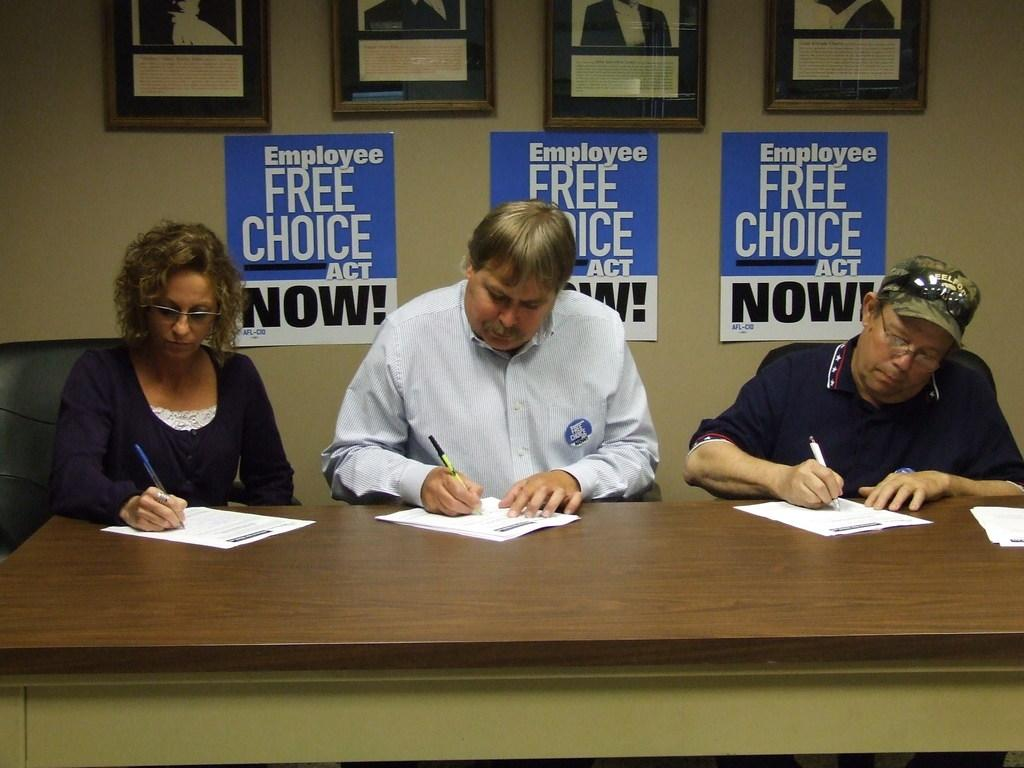How many people are in the image? There are three persons in the image. What are the persons doing in the image? The persons are sitting on chairs and writing on a paper. Where is the paper located? The paper is on a table. What can be seen on the wall in the image? There are photos and other papers attached to the wall. What is the current month in the image? There is no information about the month in the image. How does the water flow in the image? There is no water present in the image. 